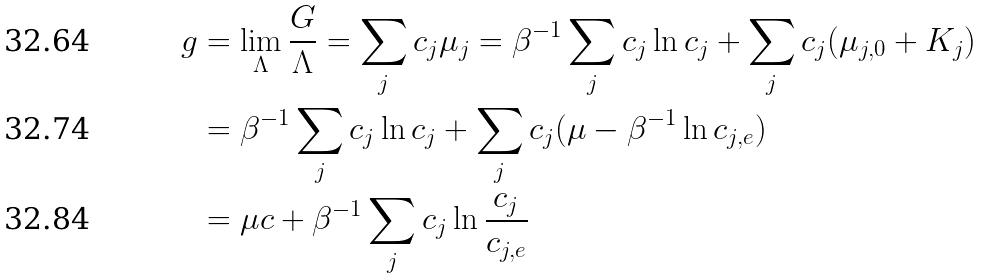<formula> <loc_0><loc_0><loc_500><loc_500>g & = \lim _ { \Lambda } \frac { G } { \Lambda } = \sum _ { j } c _ { j } \mu _ { j } = \beta ^ { - 1 } \sum _ { j } c _ { j } \ln c _ { j } + \sum _ { j } c _ { j } ( \mu _ { j , 0 } + K _ { j } ) \\ & = \beta ^ { - 1 } \sum _ { j } c _ { j } \ln c _ { j } + \sum _ { j } c _ { j } ( \mu - \beta ^ { - 1 } \ln c _ { j , e } ) \\ & = \mu c + \beta ^ { - 1 } \sum _ { j } c _ { j } \ln \frac { c _ { j } } { c _ { j , e } }</formula> 